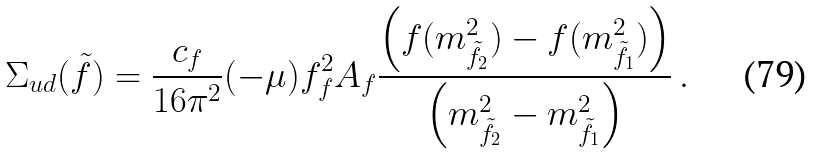Convert formula to latex. <formula><loc_0><loc_0><loc_500><loc_500>\Sigma _ { u d } ( \tilde { f } ) = \frac { c _ { f } } { 1 6 \pi ^ { 2 } } ( - \mu ) f ^ { 2 } _ { f } A _ { f } \frac { \left ( f ( m _ { \tilde { f } _ { 2 } } ^ { 2 } ) - f ( m _ { \tilde { f } _ { 1 } } ^ { 2 } ) \right ) } { \left ( m _ { \tilde { f } _ { 2 } } ^ { 2 } - m _ { \tilde { f } _ { 1 } } ^ { 2 } \right ) } \, .</formula> 